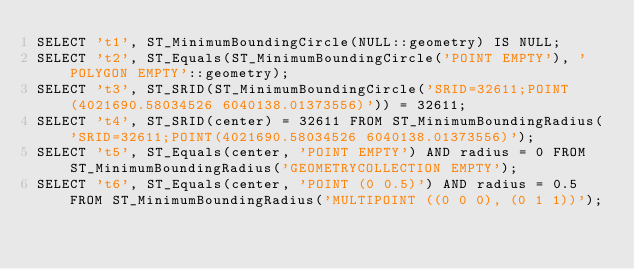Convert code to text. <code><loc_0><loc_0><loc_500><loc_500><_SQL_>SELECT 't1', ST_MinimumBoundingCircle(NULL::geometry) IS NULL;
SELECT 't2', ST_Equals(ST_MinimumBoundingCircle('POINT EMPTY'), 'POLYGON EMPTY'::geometry);
SELECT 't3', ST_SRID(ST_MinimumBoundingCircle('SRID=32611;POINT(4021690.58034526 6040138.01373556)')) = 32611;
SELECT 't4', ST_SRID(center) = 32611 FROM ST_MinimumBoundingRadius('SRID=32611;POINT(4021690.58034526 6040138.01373556)');
SELECT 't5', ST_Equals(center, 'POINT EMPTY') AND radius = 0 FROM ST_MinimumBoundingRadius('GEOMETRYCOLLECTION EMPTY');
SELECT 't6', ST_Equals(center, 'POINT (0 0.5)') AND radius = 0.5 FROM ST_MinimumBoundingRadius('MULTIPOINT ((0 0 0), (0 1 1))');
</code> 